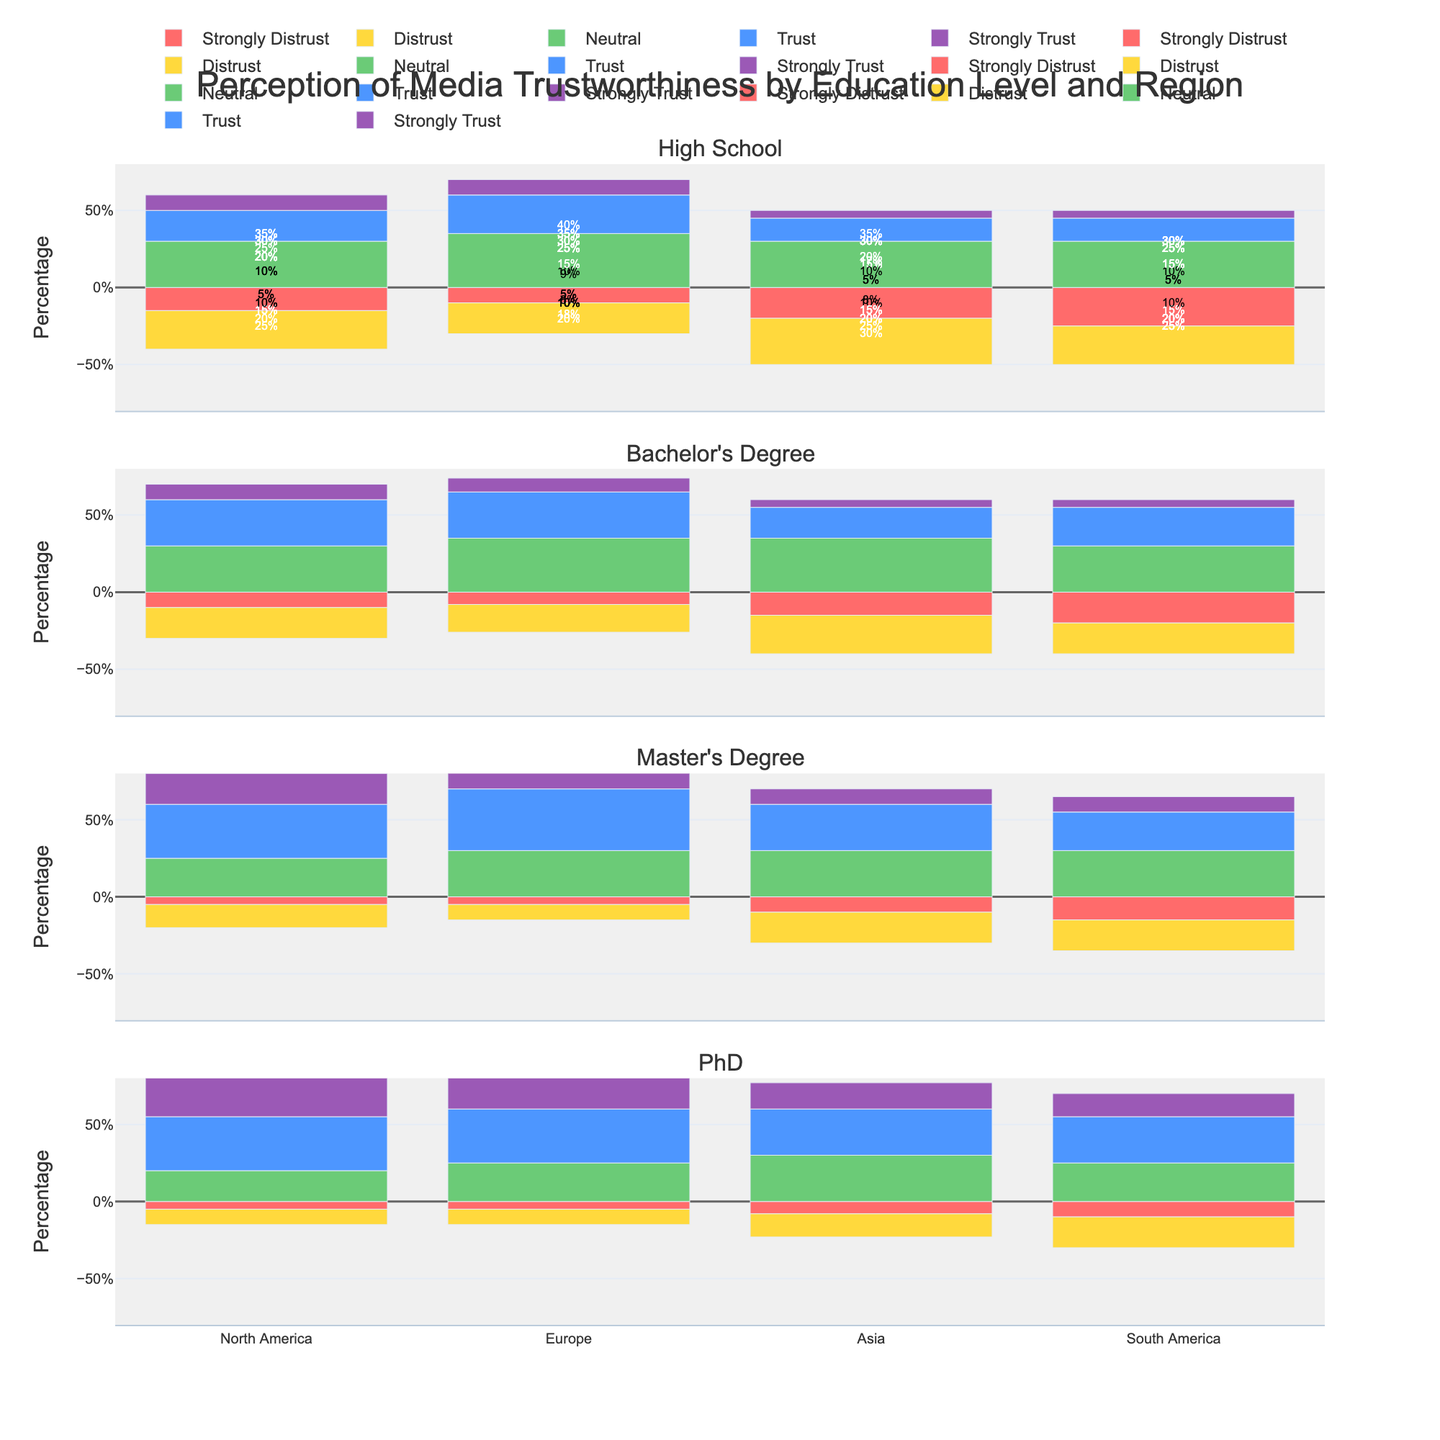What percent of people with a Bachelor's Degree in Asia strongly distrust media? Look at the bar for Bachelor's Degree in the Asia row. Identify the section colored for "Strongly Distrust." The labeled value is 15%.
Answer: 15% Compare the level of trust (Trust + Strongly Trust) between Master's Degree holders in Europe and South America. Who has a higher overall trust? Calculate the combined percentage of "Trust" and "Strongly Trust" for both regions. Europe: 40% (Trust) + 15% (Strongly Trust) = 55%. South America: 25% (Trust) + 10% (Strongly Trust) = 35%.
Answer: Europe Which group shows the highest level of strong trust in media? Identify the "Strongly Trust" sections for each group and find the maximum value. The highest value is in the PhD holders of North America with 30%.
Answer: PhD in North America What is the difference in the percentage of people who are neutral about media between Bachelor's Degree holders in North America and South America? Look at the "Neutral" sections for both regions. North America: 30%, South America: 30%. Compute the difference, which is 0%.
Answer: 0% Which region has the highest percentage of people with a High School education who distrust the media? Check the "Distrust" sections for high school education in all regions. The highest value is 30%, found in Asia.
Answer: Asia What is the overall trust level (Trust + Strongly Trust) among PhD holders in Asia compared to North America? Calculate the sums for both "Trust" and "Strongly Trust" in both regions. Asia: 30% (Trust) + 17% (Strongly Trust) = 47%. North America: 35% (Trust) + 30% (Strongly Trust) = 65%.
Answer: North America by 18% Which education level in Europe has the lowest percentage of people who strongly distrust the media? Identify the "Strongly Distrust" sections in Europe for each education level. The lowest value is for PhD holders, at 5%.
Answer: PhD Calculate the average percentage of people who trust the media (Trust) across all education levels in South America. Find the "Trust" values for all education levels in South America: High School (15%), Bachelor’s Degree (25%), Master’s Degree (25%), PhD (30%). Compute the average: (15 + 25 + 25 + 30) / 4 = 23.75%.
Answer: 23.75% How does the neutrality in media perception among Master's Degree holders compare between North America and Asia? Compare the "Neutral" sections between the two regions and find that both have the same percentage, which is 30%.
Answer: Same In which region do High School graduates show the highest level of media trust (trust + strongly trust)? Calculate the sum of "Trust" and "Strongly Trust" for High School graduates in each region. North America (30%), Europe (35%), Asia (20%), South America (20%). The highest value is in Europe with 35%.
Answer: Europe 